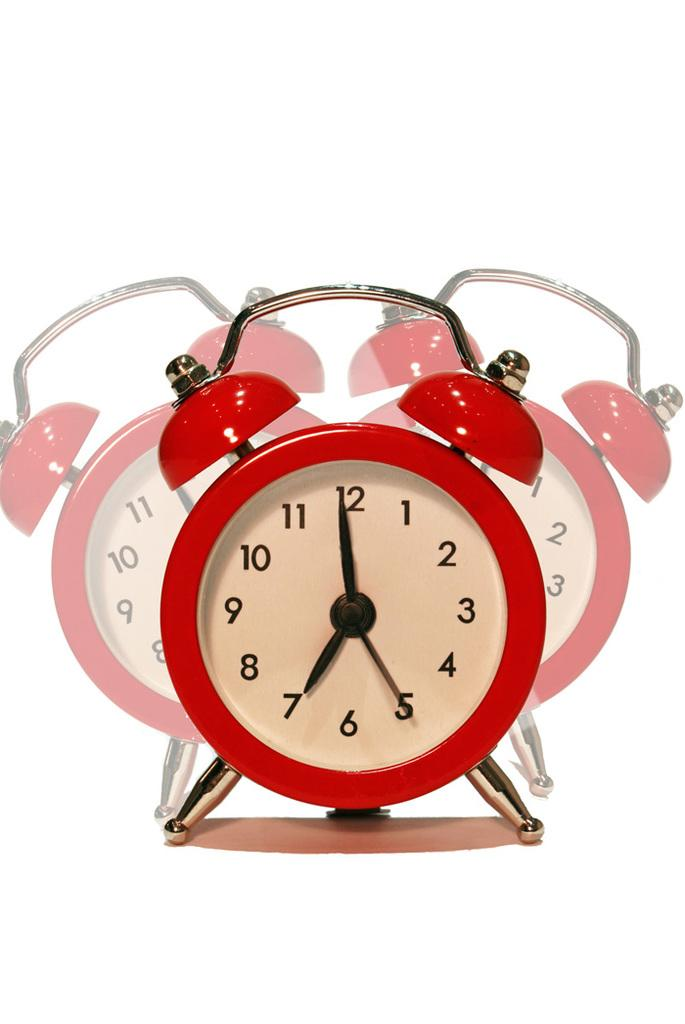<image>
Summarize the visual content of the image. A red alarm clock show the time as 6:59. 